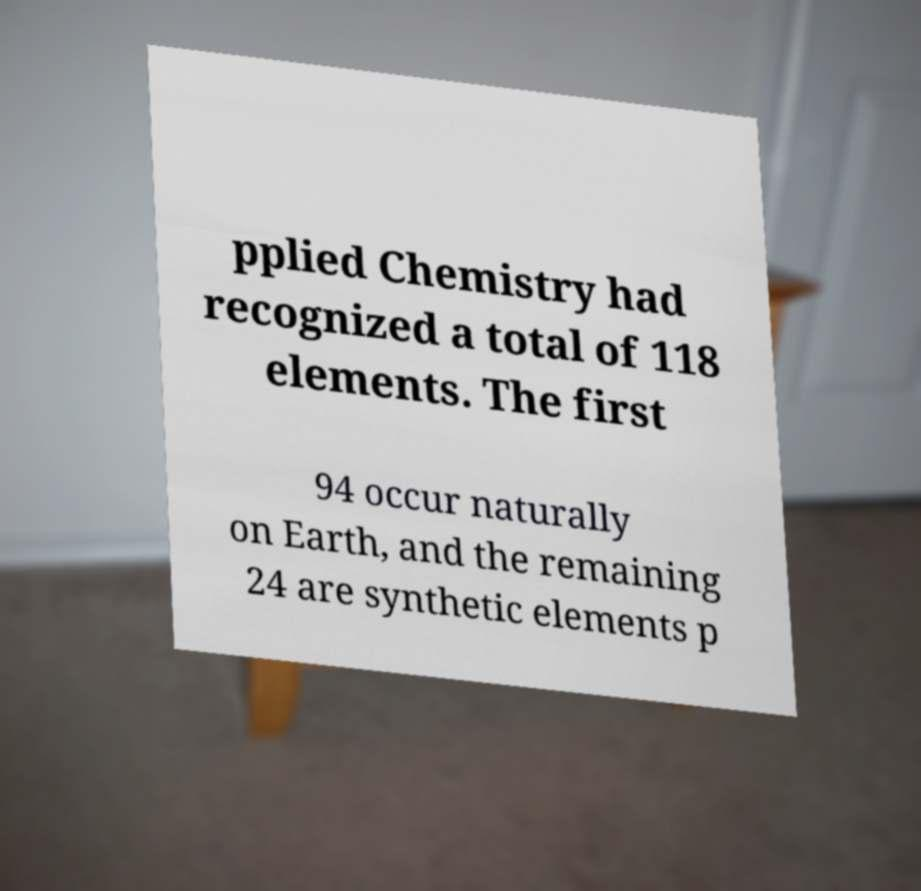There's text embedded in this image that I need extracted. Can you transcribe it verbatim? pplied Chemistry had recognized a total of 118 elements. The first 94 occur naturally on Earth, and the remaining 24 are synthetic elements p 